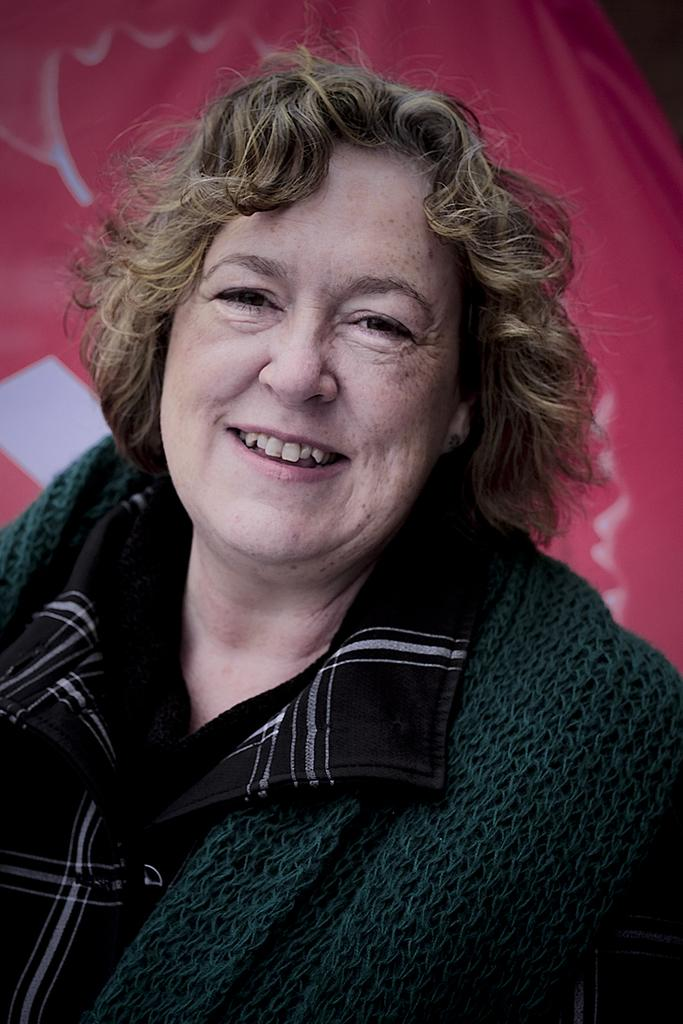Who is present in the image? There is a woman in the image. What is the woman's facial expression? The woman is smiling. What is the woman looking at? The woman is looking at something, but it is not specified in the facts. What can be seen in the background of the image? There is a pink banner in the background of the image. What type of frog is the woman holding in the image? There is no frog present in the image. What is the woman's reaction to the competition in the image? The facts do not mention any competition, and the woman is smiling, not showing any signs of anger or frustration. 